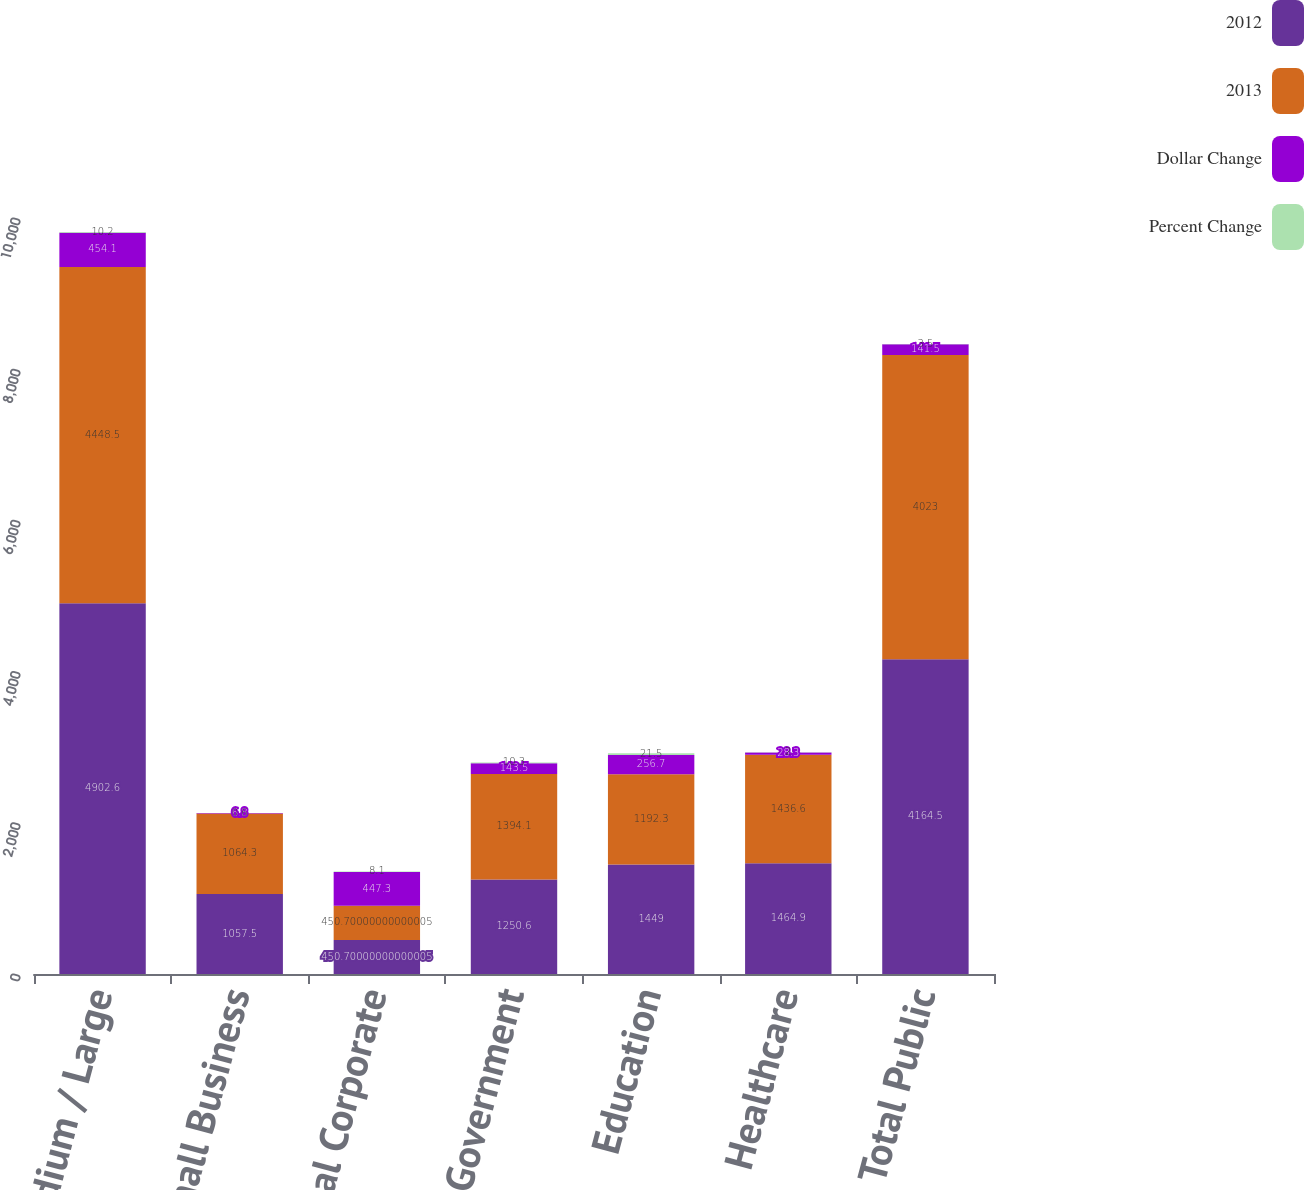<chart> <loc_0><loc_0><loc_500><loc_500><stacked_bar_chart><ecel><fcel>Medium / Large<fcel>Small Business<fcel>Total Corporate<fcel>Government<fcel>Education<fcel>Healthcare<fcel>Total Public<nl><fcel>2012<fcel>4902.6<fcel>1057.5<fcel>450.7<fcel>1250.6<fcel>1449<fcel>1464.9<fcel>4164.5<nl><fcel>2013<fcel>4448.5<fcel>1064.3<fcel>450.7<fcel>1394.1<fcel>1192.3<fcel>1436.6<fcel>4023<nl><fcel>Dollar Change<fcel>454.1<fcel>6.8<fcel>447.3<fcel>143.5<fcel>256.7<fcel>28.3<fcel>141.5<nl><fcel>Percent Change<fcel>10.2<fcel>0.6<fcel>8.1<fcel>10.3<fcel>21.5<fcel>2<fcel>3.5<nl></chart> 